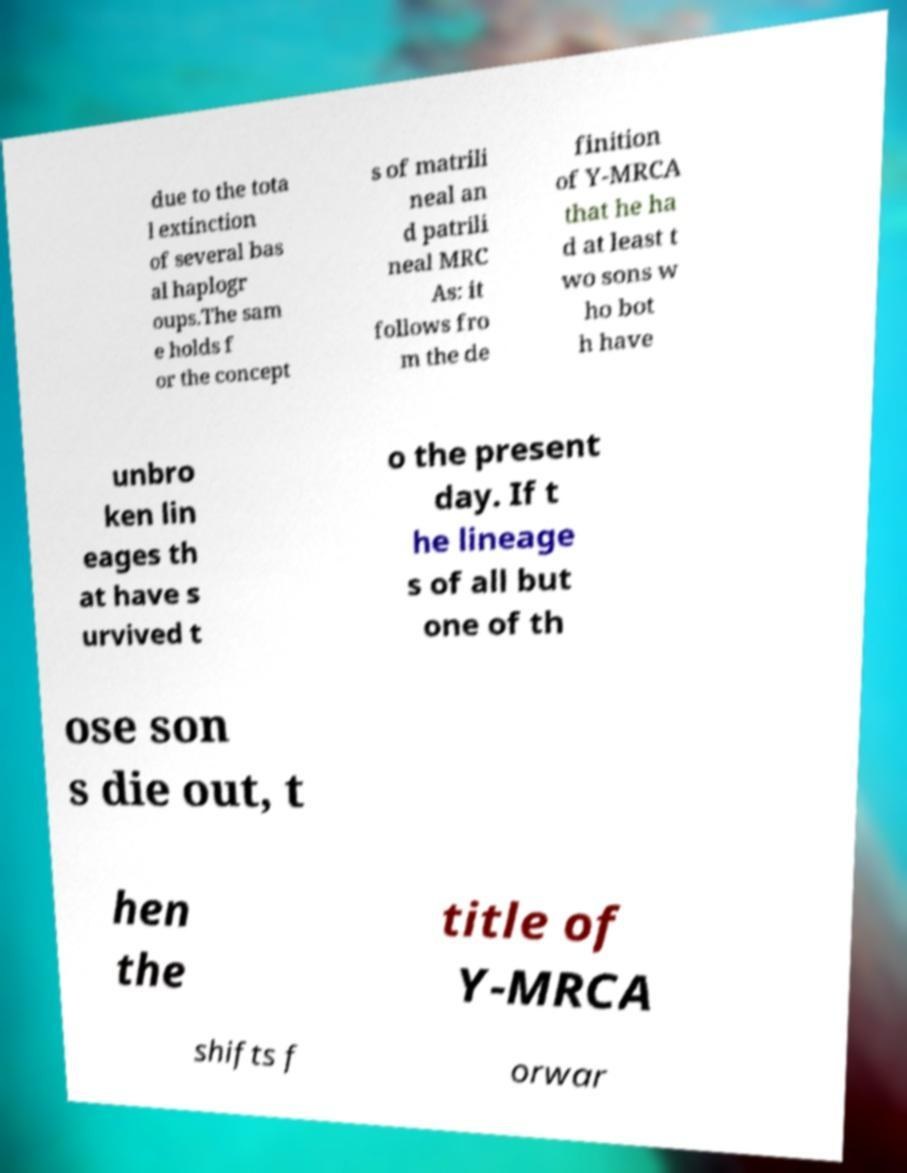Could you assist in decoding the text presented in this image and type it out clearly? due to the tota l extinction of several bas al haplogr oups.The sam e holds f or the concept s of matrili neal an d patrili neal MRC As: it follows fro m the de finition of Y-MRCA that he ha d at least t wo sons w ho bot h have unbro ken lin eages th at have s urvived t o the present day. If t he lineage s of all but one of th ose son s die out, t hen the title of Y-MRCA shifts f orwar 